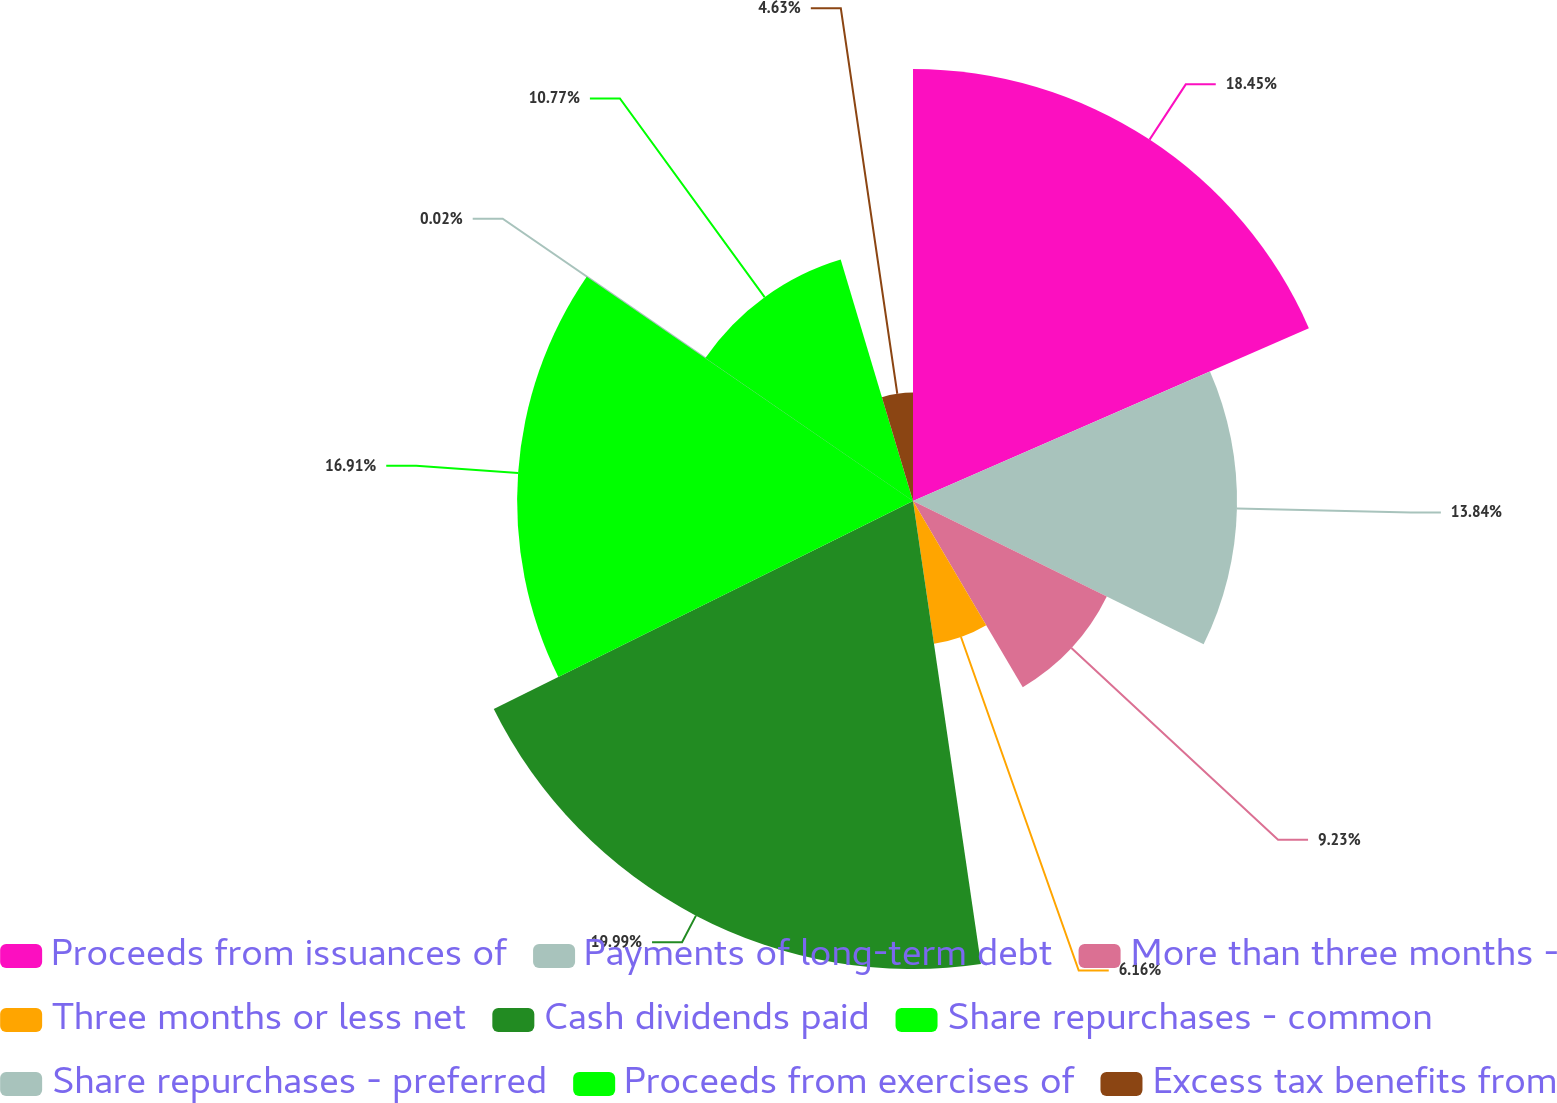<chart> <loc_0><loc_0><loc_500><loc_500><pie_chart><fcel>Proceeds from issuances of<fcel>Payments of long-term debt<fcel>More than three months -<fcel>Three months or less net<fcel>Cash dividends paid<fcel>Share repurchases - common<fcel>Share repurchases - preferred<fcel>Proceeds from exercises of<fcel>Excess tax benefits from<nl><fcel>18.45%<fcel>13.84%<fcel>9.23%<fcel>6.16%<fcel>19.99%<fcel>16.91%<fcel>0.02%<fcel>10.77%<fcel>4.63%<nl></chart> 